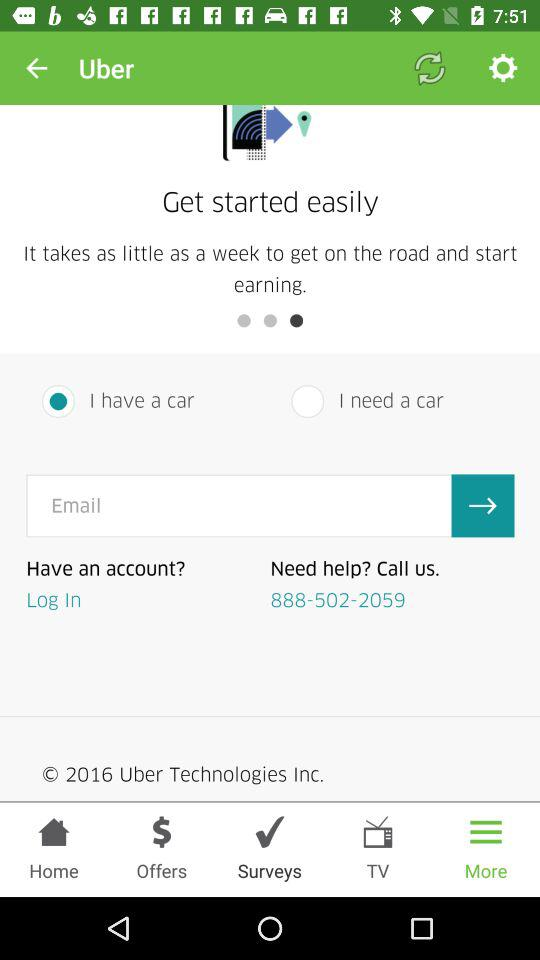Which option is selected, "I have a car" or "I need a car"? The selected option is "I have a car". 